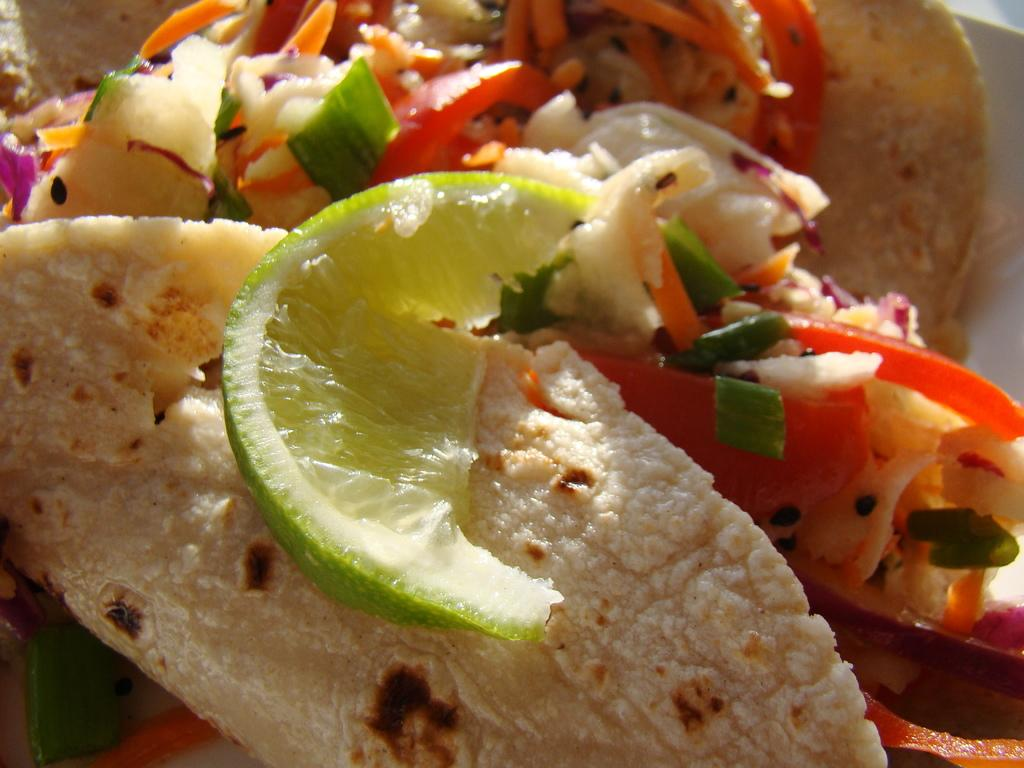What type of sweet is in the image? There is a piece of sweet lemon in the image. What other food item can be seen in the image? There is a tortilla in the image. Can you describe any other food items present in the image? Yes, there are other food items present in the image. What type of headwear is the lemon wearing in the image? There is no headwear present on the lemon in the image. What class of food does the tortilla belong to in the image? The facts provided do not specify a class of food for the tortilla. 